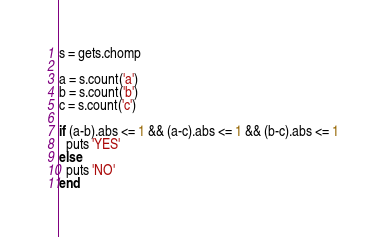Convert code to text. <code><loc_0><loc_0><loc_500><loc_500><_Ruby_>s = gets.chomp

a = s.count('a')
b = s.count('b')
c = s.count('c')

if (a-b).abs <= 1 && (a-c).abs <= 1 && (b-c).abs <= 1
  puts 'YES'
else
  puts 'NO'
end</code> 